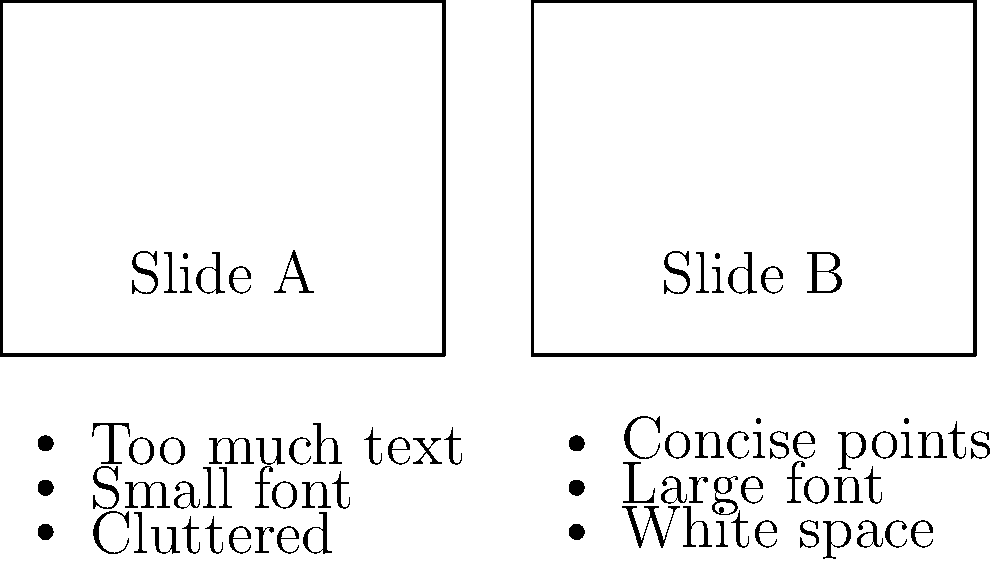Which slide layout is more effective for a clear and impactful presentation, and why? To determine the more effective slide layout, let's analyze both slides:

1. Slide A:
   - Title: "Slide A"
   - Bullet points: "Too much text", "Small font", "Cluttered"
   These characteristics suggest a poorly designed slide that may overwhelm the audience.

2. Slide B:
   - Title: "Slide B"
   - Bullet points: "Concise points", "Large font", "White space"
   These features indicate a well-designed slide that is easier to read and understand.

3. Effectiveness comparison:
   a. Conciseness: Slide B emphasizes concise points, which helps maintain audience attention.
   b. Readability: Slide B uses a larger font, making it easier for the audience to read from a distance.
   c. Visual appeal: Slide B incorporates white space, reducing clutter and improving overall aesthetics.

4. Impact on communication:
   - Slide B's layout supports better communication by allowing the presenter to elaborate on key points verbally.
   - The audience can quickly grasp the main ideas without being overwhelmed by excessive text.

5. Audience engagement:
   - Slide B's clean design is more likely to keep the audience focused on the presenter and the core message.

Therefore, Slide B is more effective for a clear and impactful presentation due to its concise content, improved readability, and better use of visual space.
Answer: Slide B, due to concise content, larger font, and better use of white space. 